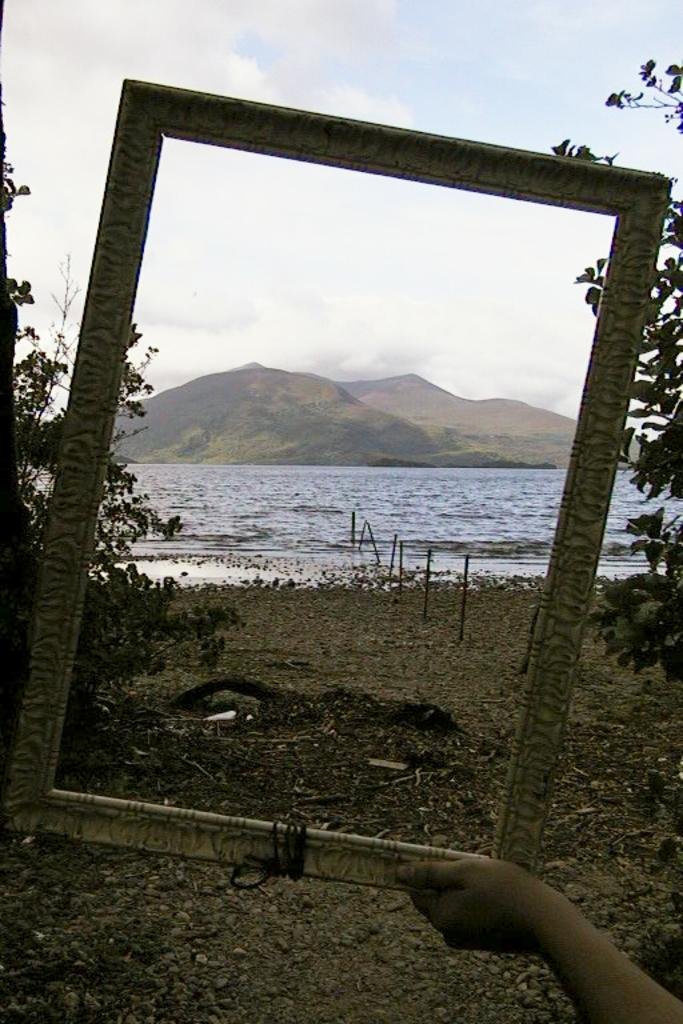What is being held in the image? A human hand is holding the frame in the image. What can be seen in the middle of the image? There is water in the middle of the image. What type of landscape is visible in the background of the image? There are hills visible at the back side of the image. How would you describe the weather in the image? The sky is cloudy in the image. What type of alarm is being sounded in the image? There is no alarm present in the image. Is there a watch visible on the hand holding the frame? The provided facts do not mention a watch, so we cannot determine if one is visible. Can you see a tank in the image? There is no tank present in the image. 